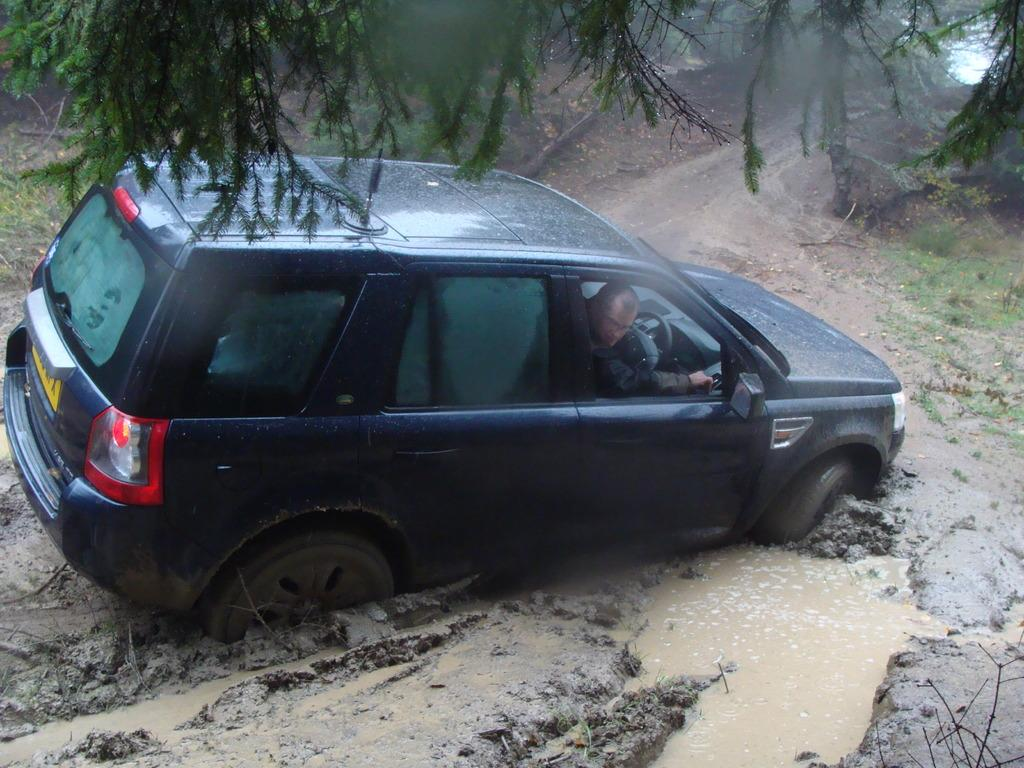What is the main subject of the image? There is a car in the image. Can you describe the person inside the car? There is a man inside the car. What type of natural environment is visible in the image? There is grass, mud, water, and leaves visible in the image. What idea does the police officer have about the car in the image? There is no police officer present in the image, so it is not possible to determine any ideas they might have about the car. 